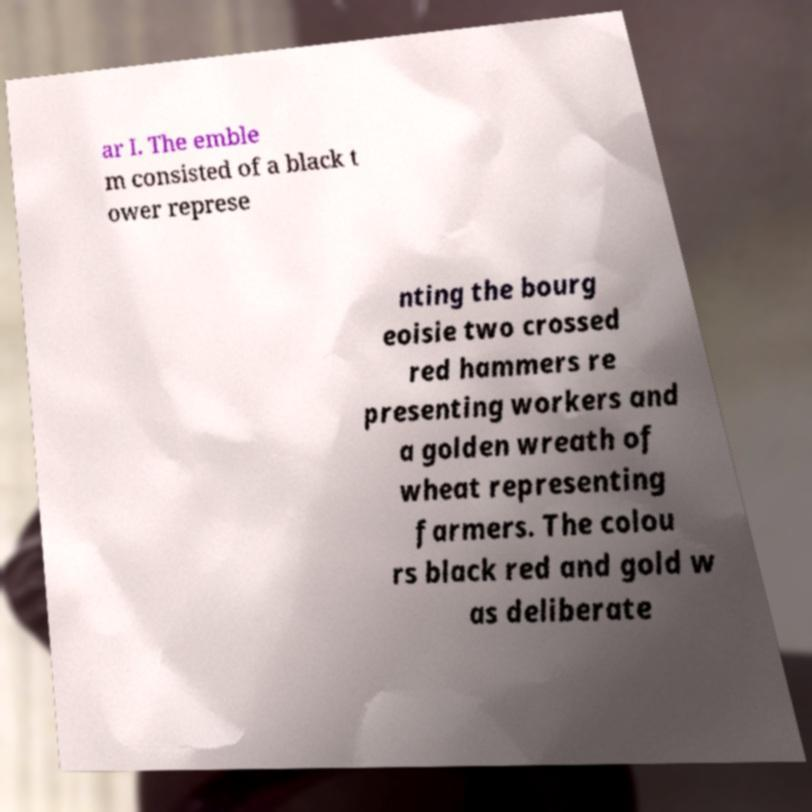What messages or text are displayed in this image? I need them in a readable, typed format. ar I. The emble m consisted of a black t ower represe nting the bourg eoisie two crossed red hammers re presenting workers and a golden wreath of wheat representing farmers. The colou rs black red and gold w as deliberate 